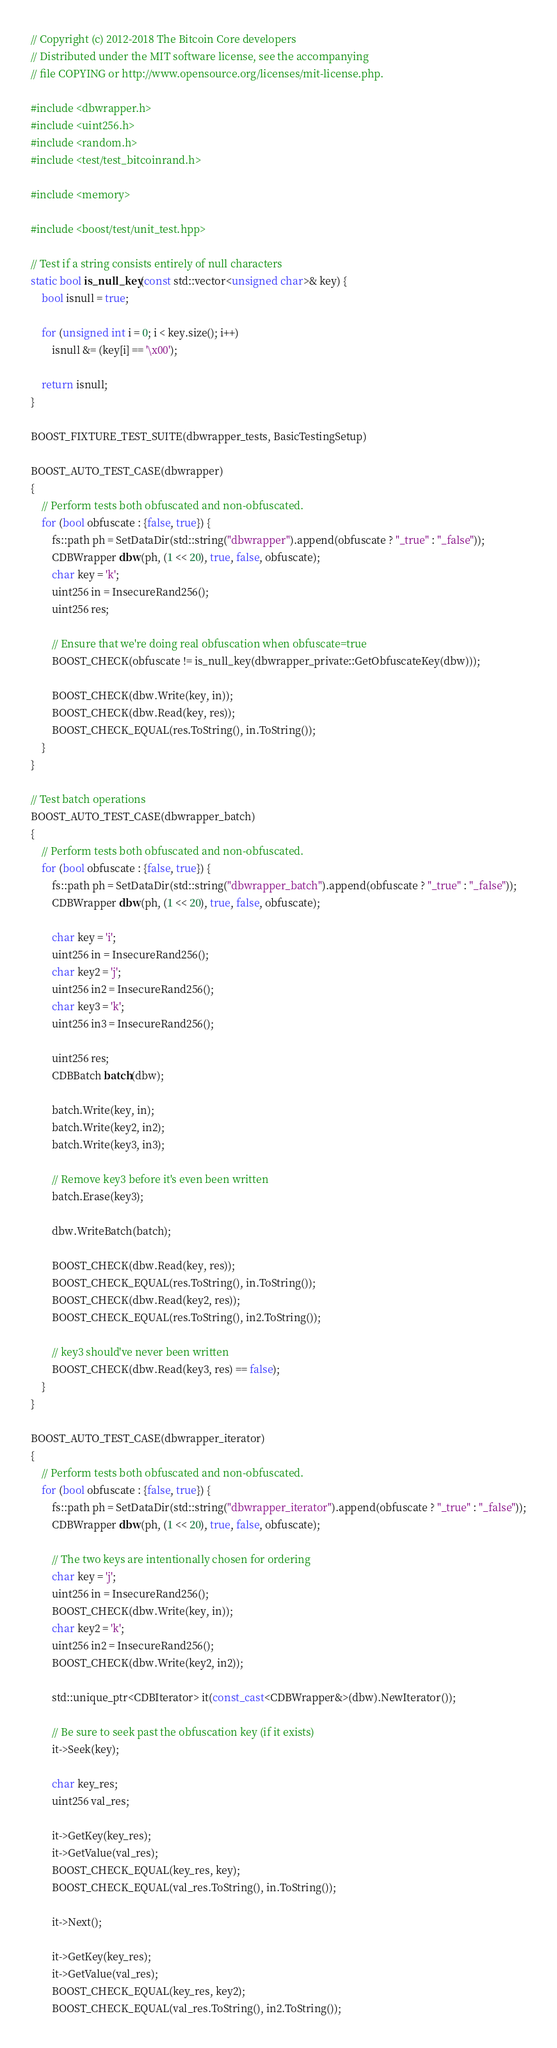<code> <loc_0><loc_0><loc_500><loc_500><_C++_>// Copyright (c) 2012-2018 The Bitcoin Core developers
// Distributed under the MIT software license, see the accompanying
// file COPYING or http://www.opensource.org/licenses/mit-license.php.

#include <dbwrapper.h>
#include <uint256.h>
#include <random.h>
#include <test/test_bitcoinrand.h>

#include <memory>

#include <boost/test/unit_test.hpp>

// Test if a string consists entirely of null characters
static bool is_null_key(const std::vector<unsigned char>& key) {
    bool isnull = true;

    for (unsigned int i = 0; i < key.size(); i++)
        isnull &= (key[i] == '\x00');

    return isnull;
}

BOOST_FIXTURE_TEST_SUITE(dbwrapper_tests, BasicTestingSetup)

BOOST_AUTO_TEST_CASE(dbwrapper)
{
    // Perform tests both obfuscated and non-obfuscated.
    for (bool obfuscate : {false, true}) {
        fs::path ph = SetDataDir(std::string("dbwrapper").append(obfuscate ? "_true" : "_false"));
        CDBWrapper dbw(ph, (1 << 20), true, false, obfuscate);
        char key = 'k';
        uint256 in = InsecureRand256();
        uint256 res;

        // Ensure that we're doing real obfuscation when obfuscate=true
        BOOST_CHECK(obfuscate != is_null_key(dbwrapper_private::GetObfuscateKey(dbw)));

        BOOST_CHECK(dbw.Write(key, in));
        BOOST_CHECK(dbw.Read(key, res));
        BOOST_CHECK_EQUAL(res.ToString(), in.ToString());
    }
}

// Test batch operations
BOOST_AUTO_TEST_CASE(dbwrapper_batch)
{
    // Perform tests both obfuscated and non-obfuscated.
    for (bool obfuscate : {false, true}) {
        fs::path ph = SetDataDir(std::string("dbwrapper_batch").append(obfuscate ? "_true" : "_false"));
        CDBWrapper dbw(ph, (1 << 20), true, false, obfuscate);

        char key = 'i';
        uint256 in = InsecureRand256();
        char key2 = 'j';
        uint256 in2 = InsecureRand256();
        char key3 = 'k';
        uint256 in3 = InsecureRand256();

        uint256 res;
        CDBBatch batch(dbw);

        batch.Write(key, in);
        batch.Write(key2, in2);
        batch.Write(key3, in3);

        // Remove key3 before it's even been written
        batch.Erase(key3);

        dbw.WriteBatch(batch);

        BOOST_CHECK(dbw.Read(key, res));
        BOOST_CHECK_EQUAL(res.ToString(), in.ToString());
        BOOST_CHECK(dbw.Read(key2, res));
        BOOST_CHECK_EQUAL(res.ToString(), in2.ToString());

        // key3 should've never been written
        BOOST_CHECK(dbw.Read(key3, res) == false);
    }
}

BOOST_AUTO_TEST_CASE(dbwrapper_iterator)
{
    // Perform tests both obfuscated and non-obfuscated.
    for (bool obfuscate : {false, true}) {
        fs::path ph = SetDataDir(std::string("dbwrapper_iterator").append(obfuscate ? "_true" : "_false"));
        CDBWrapper dbw(ph, (1 << 20), true, false, obfuscate);

        // The two keys are intentionally chosen for ordering
        char key = 'j';
        uint256 in = InsecureRand256();
        BOOST_CHECK(dbw.Write(key, in));
        char key2 = 'k';
        uint256 in2 = InsecureRand256();
        BOOST_CHECK(dbw.Write(key2, in2));

        std::unique_ptr<CDBIterator> it(const_cast<CDBWrapper&>(dbw).NewIterator());

        // Be sure to seek past the obfuscation key (if it exists)
        it->Seek(key);

        char key_res;
        uint256 val_res;

        it->GetKey(key_res);
        it->GetValue(val_res);
        BOOST_CHECK_EQUAL(key_res, key);
        BOOST_CHECK_EQUAL(val_res.ToString(), in.ToString());

        it->Next();

        it->GetKey(key_res);
        it->GetValue(val_res);
        BOOST_CHECK_EQUAL(key_res, key2);
        BOOST_CHECK_EQUAL(val_res.ToString(), in2.ToString());
</code> 